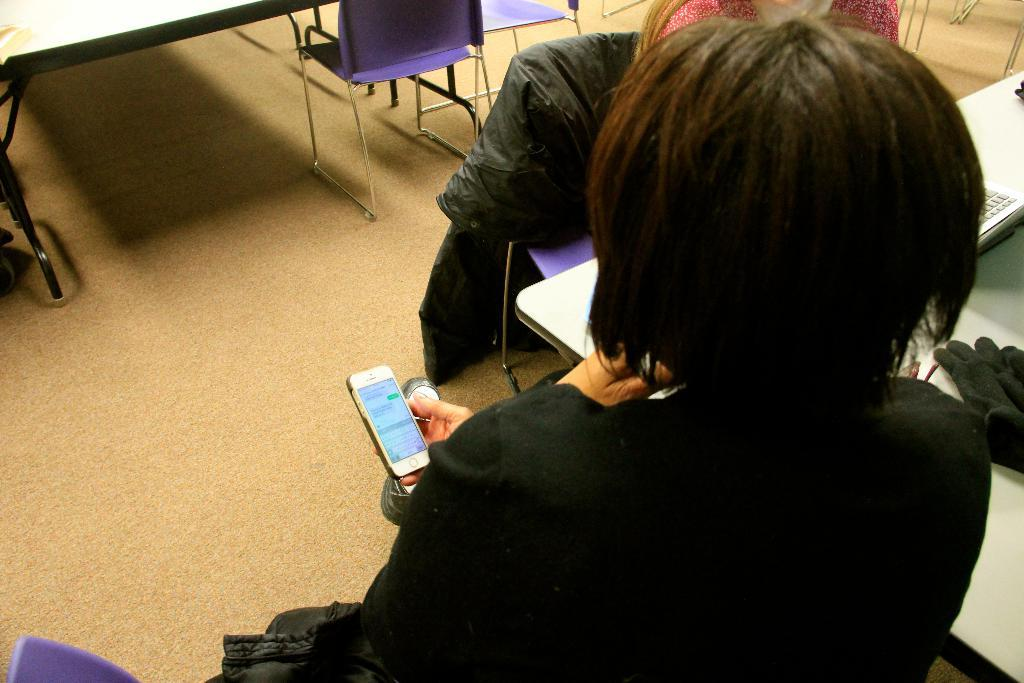How many people are sitting in the image? There are two persons sitting on chairs in the image. What is one person holding? One person is holding a mobile. What object can be seen on the table? There is a keyboard and a glove on the table. What part of the room is visible in the image? The floor is visible in the image. What is the reason for the grandmother's visit in the image? There is no mention of a grandmother or her visit in the image. 